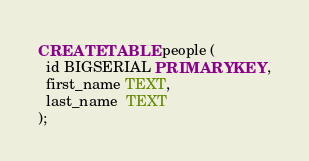<code> <loc_0><loc_0><loc_500><loc_500><_SQL_>CREATE TABLE people (
  id BIGSERIAL PRIMARY KEY,
  first_name TEXT,
  last_name  TEXT
);
</code> 